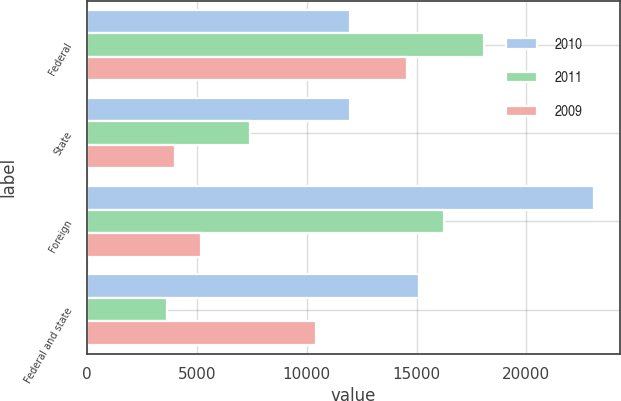<chart> <loc_0><loc_0><loc_500><loc_500><stacked_bar_chart><ecel><fcel>Federal<fcel>State<fcel>Foreign<fcel>Federal and state<nl><fcel>2010<fcel>11969<fcel>11969<fcel>23101<fcel>15117<nl><fcel>2011<fcel>18085<fcel>7412<fcel>16232<fcel>3654<nl><fcel>2009<fcel>14571<fcel>4008<fcel>5169<fcel>10412<nl></chart> 